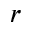<formula> <loc_0><loc_0><loc_500><loc_500>r</formula> 